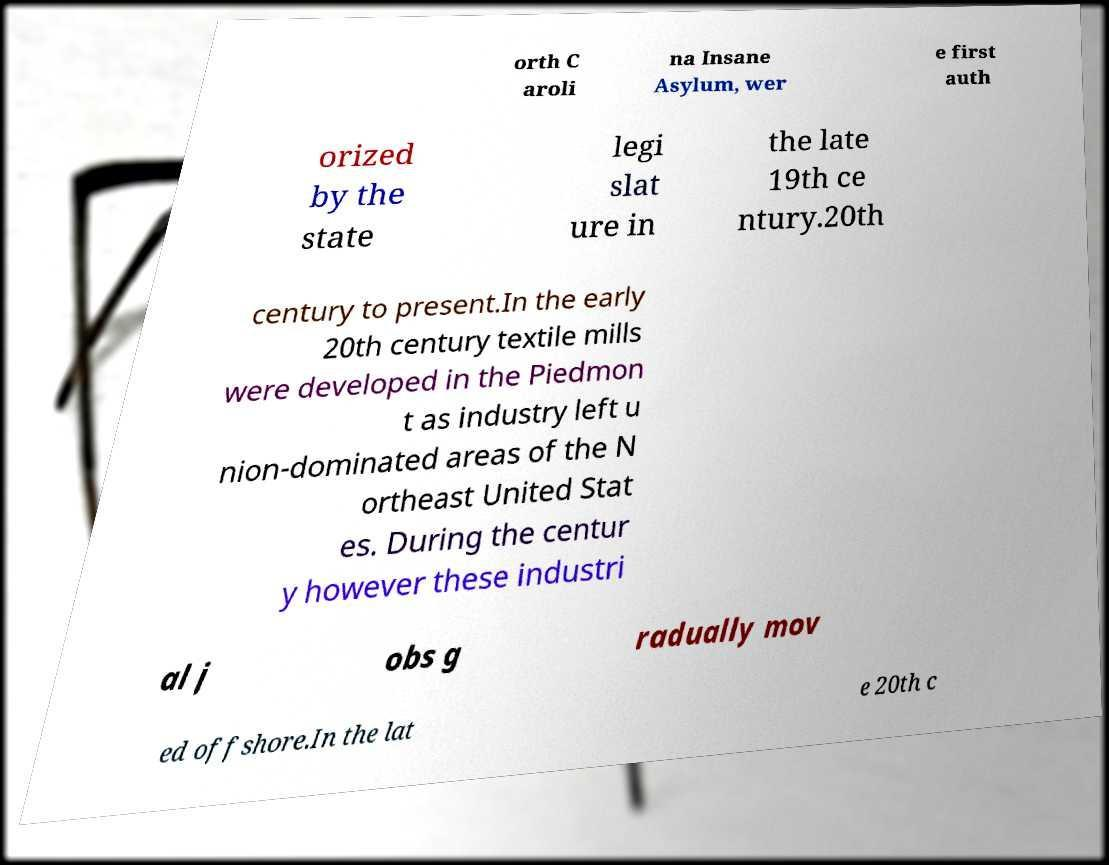I need the written content from this picture converted into text. Can you do that? orth C aroli na Insane Asylum, wer e first auth orized by the state legi slat ure in the late 19th ce ntury.20th century to present.In the early 20th century textile mills were developed in the Piedmon t as industry left u nion-dominated areas of the N ortheast United Stat es. During the centur y however these industri al j obs g radually mov ed offshore.In the lat e 20th c 